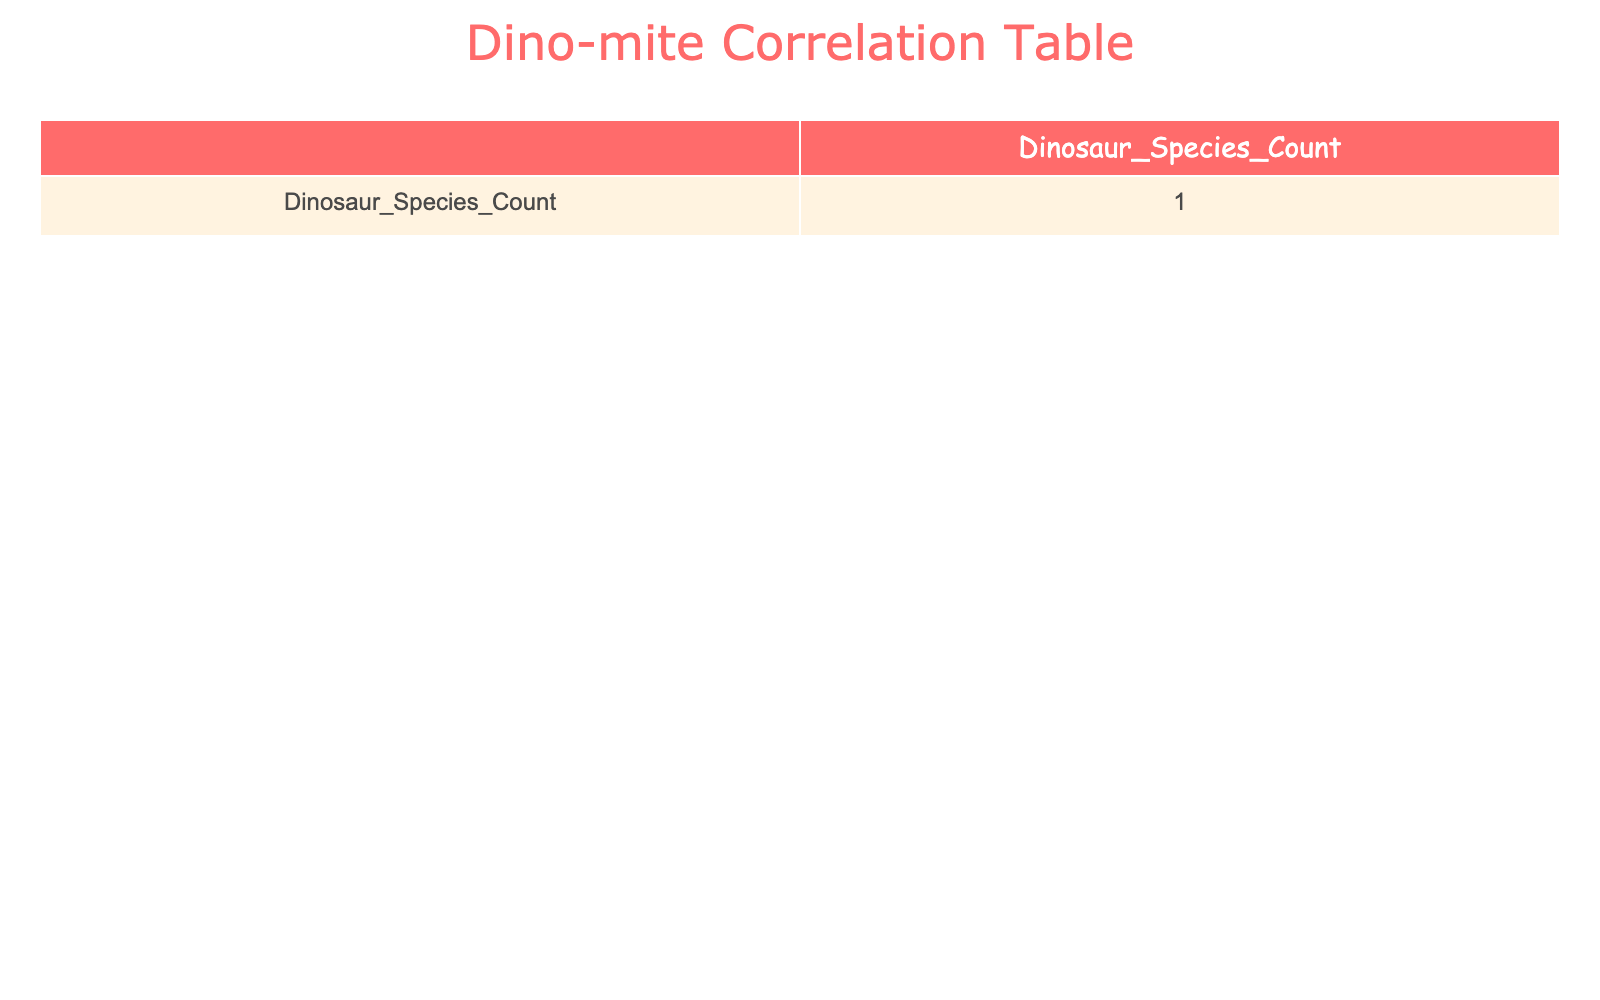What is the Dinosaur Species Count for Alberta? You can find the information by looking at the row for Alberta in the table. It shows a Dinosaur Species Count of 36.
Answer: 36 Which location has the highest Dinosaur Species Count? By scanning the Dinosaur Species Count, Argentina with 45 species stands out as the highest.
Answer: Argentina What is the average Dinosaur Species Count for the provided locations? First, add the Dinosaur Species Counts: 27 + 32 + 25 + 36 + 42 + 45 + 29 + 19 + 15 + 10 =  310. Then divide by the number of locations, which is 10. So the average is 310/10 = 31.
Answer: 31 Is it true that Texas has more Dinosaur Species Count than Colorado? Compare the Dinosaur Species Counts for Texas (29) and Colorado (25). Since 29 is greater than 25, the statement is true.
Answer: Yes How many more Dinosaur Species does China have compared to Tennessee? Look at the counts: China has 42 and Tennessee has 10. The difference is calculated as 42 - 10 = 32.
Answer: 32 Which states have a Dinosaur Species Count greater than 30? Reviewing the Dinosaur Species Counts shows that Utah (32), Alberta (36), China (42), and Argentina (45) all have counts greater than 30.
Answer: Utah, Alberta, China, Argentina What is the total Dinosaur Species Count for locations that are in the U.S.? Add the counts for Montana (27), Utah (32), Colorado (25), Texas (29), South Dakota (19), New Mexico (15), and Tennessee (10): 27 + 32 + 25 + 29 + 19 + 15 + 10 =  157.
Answer: 157 Are there any locations with a Dinosaur Species Count below 20? Checking the counts, South Dakota (19) and New Mexico (15) are both below 20, confirming that there are locations meeting this criterion.
Answer: Yes What is the difference between the highest and lowest Dinosaur Species Counts? The highest count is 45 (Argentina) and the lowest is 10 (Tennessee). The difference is 45 - 10 = 35.
Answer: 35 